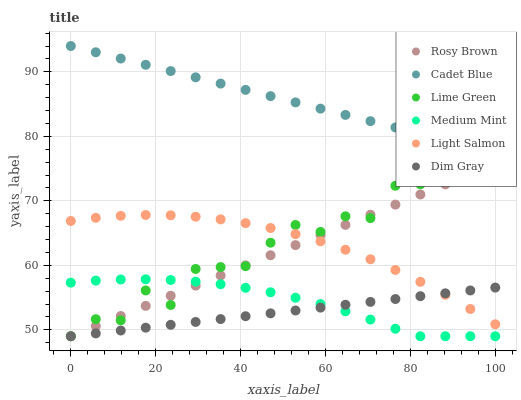Does Dim Gray have the minimum area under the curve?
Answer yes or no. Yes. Does Cadet Blue have the maximum area under the curve?
Answer yes or no. Yes. Does Light Salmon have the minimum area under the curve?
Answer yes or no. No. Does Light Salmon have the maximum area under the curve?
Answer yes or no. No. Is Dim Gray the smoothest?
Answer yes or no. Yes. Is Lime Green the roughest?
Answer yes or no. Yes. Is Light Salmon the smoothest?
Answer yes or no. No. Is Light Salmon the roughest?
Answer yes or no. No. Does Medium Mint have the lowest value?
Answer yes or no. Yes. Does Light Salmon have the lowest value?
Answer yes or no. No. Does Cadet Blue have the highest value?
Answer yes or no. Yes. Does Light Salmon have the highest value?
Answer yes or no. No. Is Lime Green less than Cadet Blue?
Answer yes or no. Yes. Is Cadet Blue greater than Dim Gray?
Answer yes or no. Yes. Does Light Salmon intersect Dim Gray?
Answer yes or no. Yes. Is Light Salmon less than Dim Gray?
Answer yes or no. No. Is Light Salmon greater than Dim Gray?
Answer yes or no. No. Does Lime Green intersect Cadet Blue?
Answer yes or no. No. 